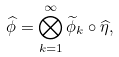Convert formula to latex. <formula><loc_0><loc_0><loc_500><loc_500>\widehat { \phi } = \bigotimes _ { k = 1 } ^ { \infty } \widetilde { \phi } _ { k } \circ \widehat { \eta } ,</formula> 